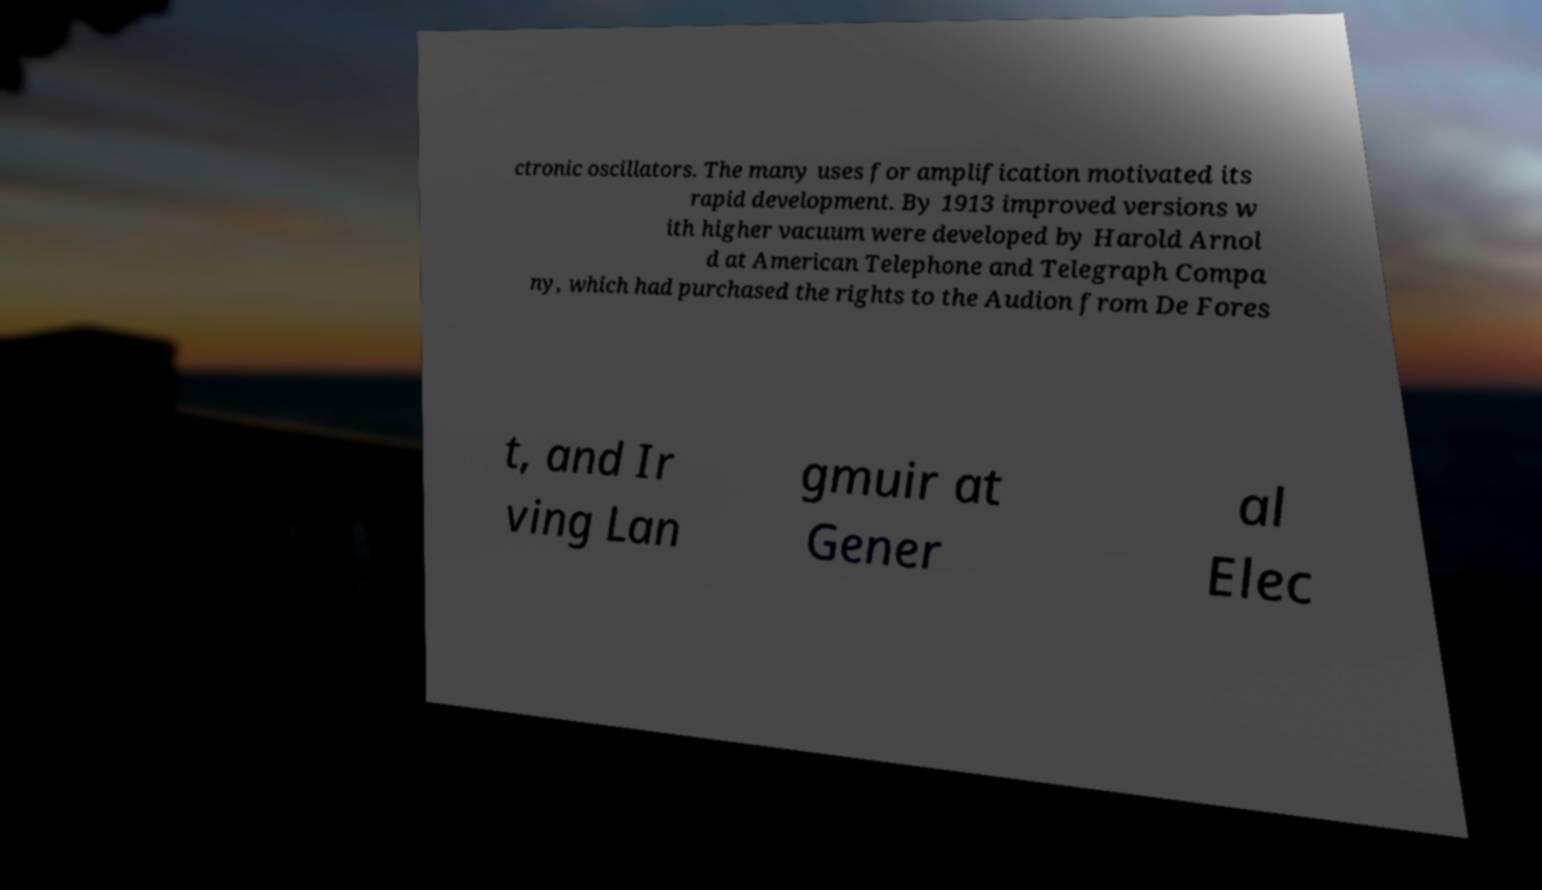Please read and relay the text visible in this image. What does it say? ctronic oscillators. The many uses for amplification motivated its rapid development. By 1913 improved versions w ith higher vacuum were developed by Harold Arnol d at American Telephone and Telegraph Compa ny, which had purchased the rights to the Audion from De Fores t, and Ir ving Lan gmuir at Gener al Elec 